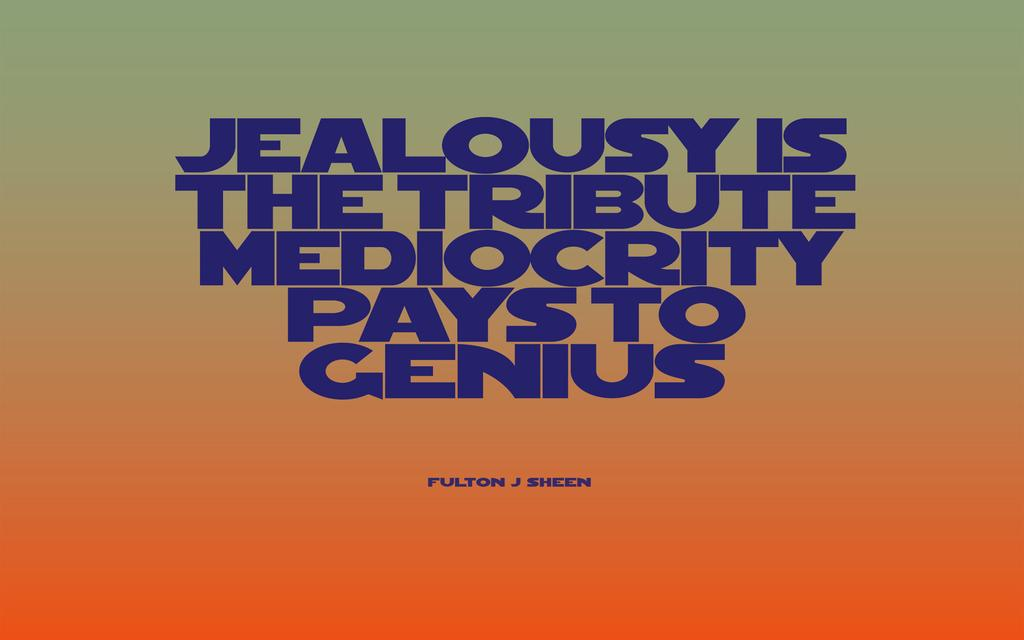Provide a one-sentence caption for the provided image. Blue lettering spells out a saying about jealousy and its relationship to genuis on a background of green fading to orange. 